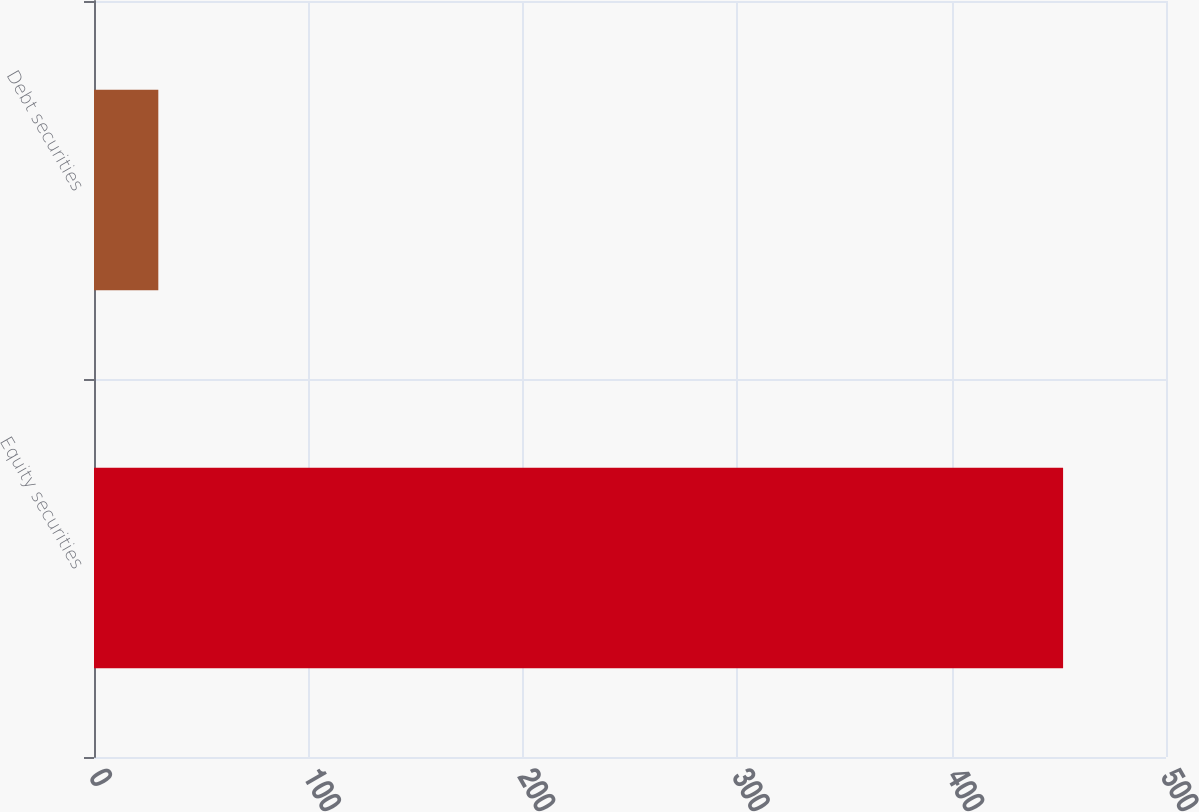<chart> <loc_0><loc_0><loc_500><loc_500><bar_chart><fcel>Equity securities<fcel>Debt securities<nl><fcel>452<fcel>30<nl></chart> 